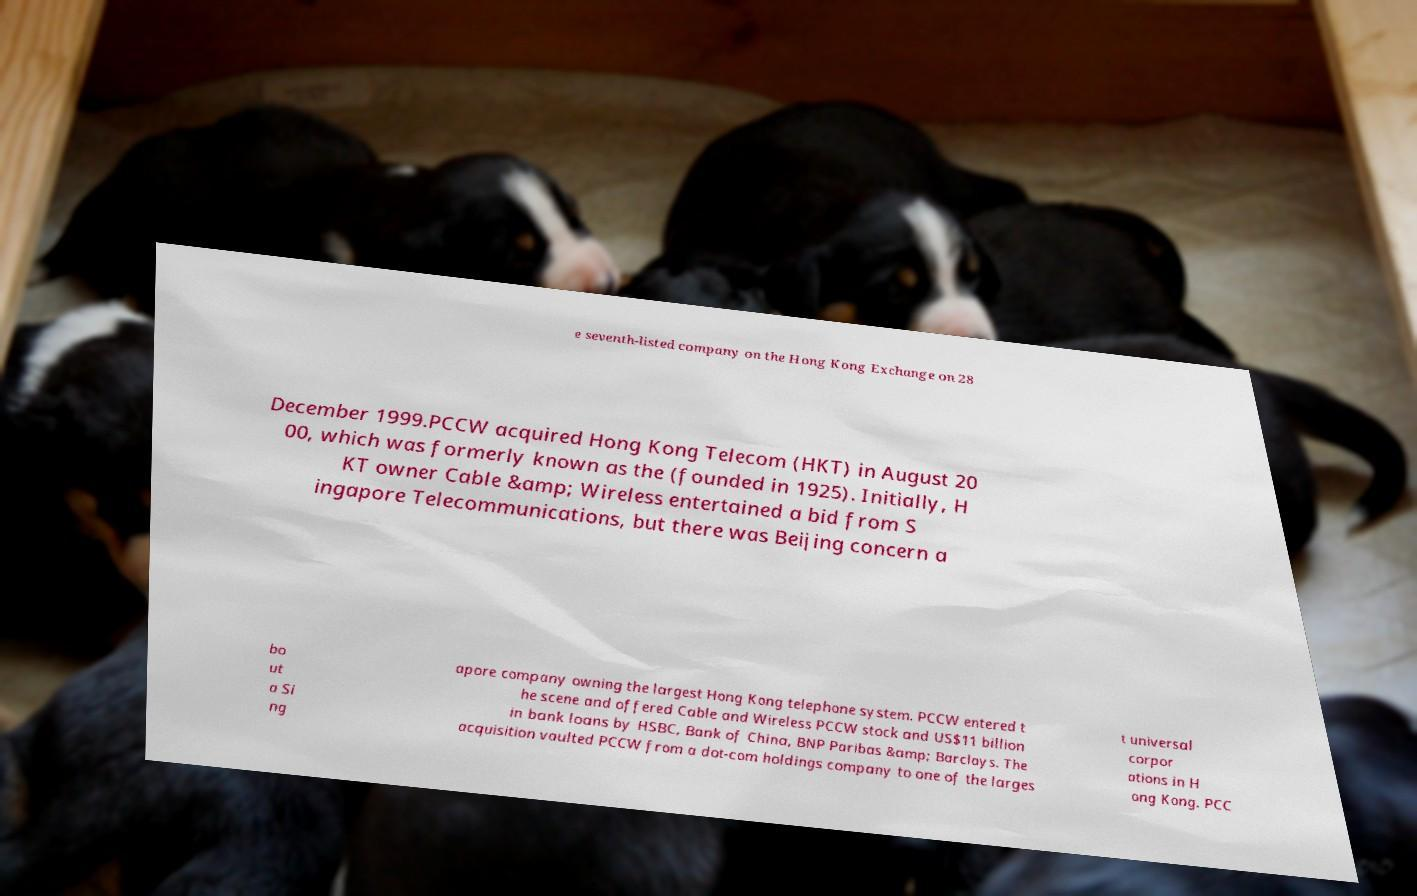Can you accurately transcribe the text from the provided image for me? e seventh-listed company on the Hong Kong Exchange on 28 December 1999.PCCW acquired Hong Kong Telecom (HKT) in August 20 00, which was formerly known as the (founded in 1925). Initially, H KT owner Cable &amp; Wireless entertained a bid from S ingapore Telecommunications, but there was Beijing concern a bo ut a Si ng apore company owning the largest Hong Kong telephone system. PCCW entered t he scene and offered Cable and Wireless PCCW stock and US$11 billion in bank loans by HSBC, Bank of China, BNP Paribas &amp; Barclays. The acquisition vaulted PCCW from a dot-com holdings company to one of the larges t universal corpor ations in H ong Kong. PCC 